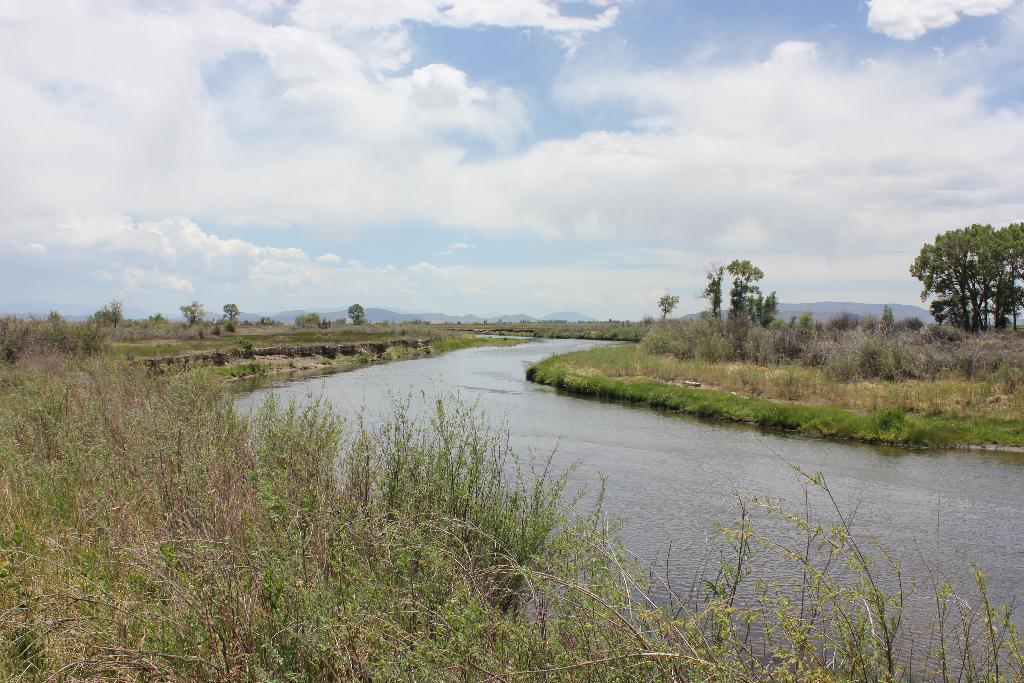Please provide a concise description of this image. This is an outside view. In the middle of the image there is a lake. On both sides of the lake there are many plants and trees. At the top of the image I can see the sky and clouds. 